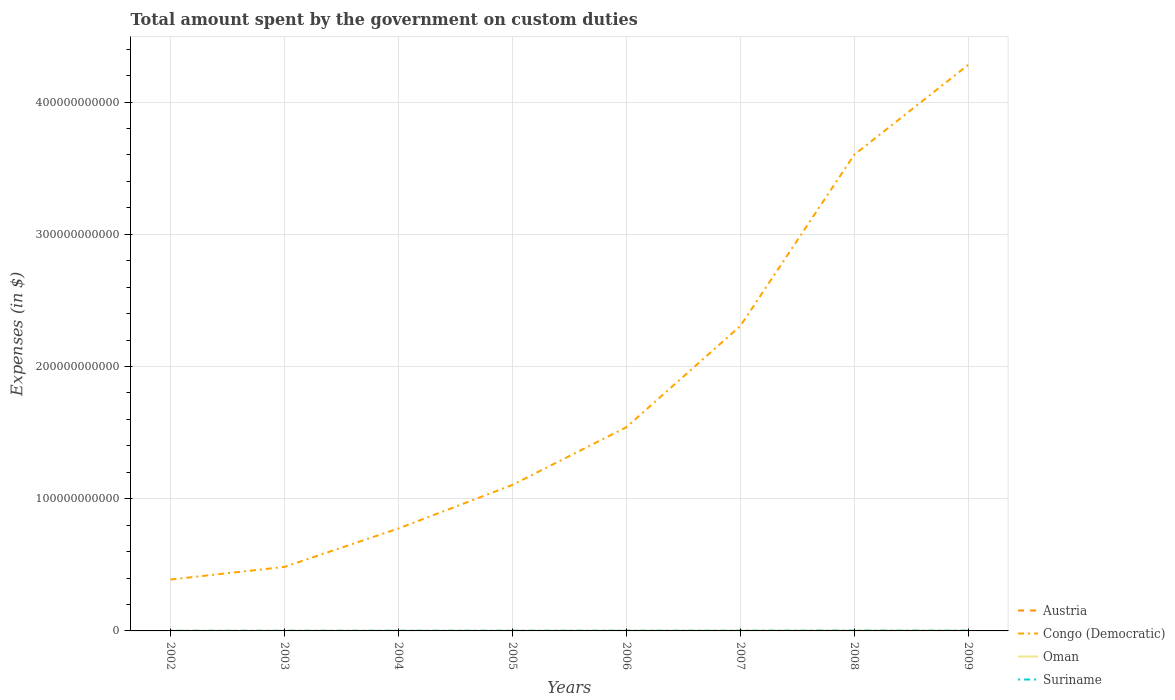How many different coloured lines are there?
Offer a terse response. 4. Does the line corresponding to Oman intersect with the line corresponding to Austria?
Keep it short and to the point. No. Is the number of lines equal to the number of legend labels?
Make the answer very short. No. Across all years, what is the maximum amount spent on custom duties by the government in Congo (Democratic)?
Provide a succinct answer. 3.89e+1. What is the total amount spent on custom duties by the government in Oman in the graph?
Offer a very short reply. -7.11e+07. What is the difference between the highest and the second highest amount spent on custom duties by the government in Austria?
Your response must be concise. 3.94e+06. What is the difference between the highest and the lowest amount spent on custom duties by the government in Congo (Democratic)?
Provide a succinct answer. 3. How many lines are there?
Your answer should be very brief. 4. How many years are there in the graph?
Provide a succinct answer. 8. What is the difference between two consecutive major ticks on the Y-axis?
Your answer should be compact. 1.00e+11. Are the values on the major ticks of Y-axis written in scientific E-notation?
Ensure brevity in your answer.  No. Does the graph contain any zero values?
Offer a terse response. Yes. Does the graph contain grids?
Your answer should be very brief. Yes. What is the title of the graph?
Provide a short and direct response. Total amount spent by the government on custom duties. What is the label or title of the X-axis?
Keep it short and to the point. Years. What is the label or title of the Y-axis?
Your response must be concise. Expenses (in $). What is the Expenses (in $) in Austria in 2002?
Make the answer very short. 0. What is the Expenses (in $) of Congo (Democratic) in 2002?
Offer a very short reply. 3.89e+1. What is the Expenses (in $) of Oman in 2002?
Provide a succinct answer. 6.02e+07. What is the Expenses (in $) of Suriname in 2002?
Your response must be concise. 1.07e+08. What is the Expenses (in $) of Austria in 2003?
Offer a very short reply. 0. What is the Expenses (in $) of Congo (Democratic) in 2003?
Provide a succinct answer. 4.84e+1. What is the Expenses (in $) of Oman in 2003?
Your answer should be very brief. 6.50e+07. What is the Expenses (in $) in Suriname in 2003?
Ensure brevity in your answer.  1.19e+08. What is the Expenses (in $) of Austria in 2004?
Your answer should be compact. 3.94e+06. What is the Expenses (in $) of Congo (Democratic) in 2004?
Your answer should be compact. 7.75e+1. What is the Expenses (in $) in Oman in 2004?
Give a very brief answer. 7.10e+07. What is the Expenses (in $) of Suriname in 2004?
Offer a terse response. 1.46e+08. What is the Expenses (in $) in Austria in 2005?
Offer a terse response. 1.43e+06. What is the Expenses (in $) of Congo (Democratic) in 2005?
Give a very brief answer. 1.10e+11. What is the Expenses (in $) in Oman in 2005?
Your response must be concise. 8.85e+07. What is the Expenses (in $) of Suriname in 2005?
Keep it short and to the point. 1.71e+08. What is the Expenses (in $) of Austria in 2006?
Your answer should be compact. 7.00e+04. What is the Expenses (in $) of Congo (Democratic) in 2006?
Your answer should be compact. 1.54e+11. What is the Expenses (in $) in Oman in 2006?
Keep it short and to the point. 1.15e+08. What is the Expenses (in $) of Suriname in 2006?
Ensure brevity in your answer.  1.60e+08. What is the Expenses (in $) in Austria in 2007?
Provide a succinct answer. 0. What is the Expenses (in $) of Congo (Democratic) in 2007?
Offer a very short reply. 2.31e+11. What is the Expenses (in $) in Oman in 2007?
Offer a very short reply. 1.60e+08. What is the Expenses (in $) in Suriname in 2007?
Provide a short and direct response. 1.85e+08. What is the Expenses (in $) of Austria in 2008?
Your answer should be compact. 0. What is the Expenses (in $) of Congo (Democratic) in 2008?
Ensure brevity in your answer.  3.60e+11. What is the Expenses (in $) in Oman in 2008?
Provide a succinct answer. 2.27e+08. What is the Expenses (in $) in Suriname in 2008?
Your answer should be compact. 2.22e+08. What is the Expenses (in $) of Congo (Democratic) in 2009?
Make the answer very short. 4.28e+11. What is the Expenses (in $) of Oman in 2009?
Keep it short and to the point. 1.58e+08. What is the Expenses (in $) of Suriname in 2009?
Make the answer very short. 2.12e+08. Across all years, what is the maximum Expenses (in $) of Austria?
Offer a very short reply. 3.94e+06. Across all years, what is the maximum Expenses (in $) in Congo (Democratic)?
Your answer should be compact. 4.28e+11. Across all years, what is the maximum Expenses (in $) in Oman?
Make the answer very short. 2.27e+08. Across all years, what is the maximum Expenses (in $) of Suriname?
Provide a short and direct response. 2.22e+08. Across all years, what is the minimum Expenses (in $) in Congo (Democratic)?
Provide a short and direct response. 3.89e+1. Across all years, what is the minimum Expenses (in $) in Oman?
Offer a terse response. 6.02e+07. Across all years, what is the minimum Expenses (in $) of Suriname?
Provide a succinct answer. 1.07e+08. What is the total Expenses (in $) in Austria in the graph?
Make the answer very short. 5.51e+06. What is the total Expenses (in $) of Congo (Democratic) in the graph?
Ensure brevity in your answer.  1.45e+12. What is the total Expenses (in $) in Oman in the graph?
Your response must be concise. 9.44e+08. What is the total Expenses (in $) of Suriname in the graph?
Keep it short and to the point. 1.32e+09. What is the difference between the Expenses (in $) of Congo (Democratic) in 2002 and that in 2003?
Keep it short and to the point. -9.55e+09. What is the difference between the Expenses (in $) in Oman in 2002 and that in 2003?
Provide a succinct answer. -4.80e+06. What is the difference between the Expenses (in $) in Suriname in 2002 and that in 2003?
Give a very brief answer. -1.16e+07. What is the difference between the Expenses (in $) of Congo (Democratic) in 2002 and that in 2004?
Make the answer very short. -3.86e+1. What is the difference between the Expenses (in $) of Oman in 2002 and that in 2004?
Offer a very short reply. -1.08e+07. What is the difference between the Expenses (in $) in Suriname in 2002 and that in 2004?
Provide a succinct answer. -3.92e+07. What is the difference between the Expenses (in $) in Congo (Democratic) in 2002 and that in 2005?
Offer a very short reply. -7.15e+1. What is the difference between the Expenses (in $) in Oman in 2002 and that in 2005?
Your response must be concise. -2.83e+07. What is the difference between the Expenses (in $) in Suriname in 2002 and that in 2005?
Your answer should be very brief. -6.34e+07. What is the difference between the Expenses (in $) of Congo (Democratic) in 2002 and that in 2006?
Your answer should be compact. -1.15e+11. What is the difference between the Expenses (in $) of Oman in 2002 and that in 2006?
Offer a terse response. -5.44e+07. What is the difference between the Expenses (in $) of Suriname in 2002 and that in 2006?
Your answer should be very brief. -5.29e+07. What is the difference between the Expenses (in $) in Congo (Democratic) in 2002 and that in 2007?
Your response must be concise. -1.92e+11. What is the difference between the Expenses (in $) of Oman in 2002 and that in 2007?
Offer a very short reply. -9.94e+07. What is the difference between the Expenses (in $) of Suriname in 2002 and that in 2007?
Your response must be concise. -7.76e+07. What is the difference between the Expenses (in $) of Congo (Democratic) in 2002 and that in 2008?
Your answer should be compact. -3.21e+11. What is the difference between the Expenses (in $) of Oman in 2002 and that in 2008?
Ensure brevity in your answer.  -1.66e+08. What is the difference between the Expenses (in $) in Suriname in 2002 and that in 2008?
Give a very brief answer. -1.15e+08. What is the difference between the Expenses (in $) in Congo (Democratic) in 2002 and that in 2009?
Keep it short and to the point. -3.89e+11. What is the difference between the Expenses (in $) in Oman in 2002 and that in 2009?
Offer a terse response. -9.79e+07. What is the difference between the Expenses (in $) in Suriname in 2002 and that in 2009?
Your answer should be very brief. -1.05e+08. What is the difference between the Expenses (in $) of Congo (Democratic) in 2003 and that in 2004?
Offer a very short reply. -2.91e+1. What is the difference between the Expenses (in $) of Oman in 2003 and that in 2004?
Offer a very short reply. -6.00e+06. What is the difference between the Expenses (in $) of Suriname in 2003 and that in 2004?
Ensure brevity in your answer.  -2.77e+07. What is the difference between the Expenses (in $) in Congo (Democratic) in 2003 and that in 2005?
Offer a very short reply. -6.20e+1. What is the difference between the Expenses (in $) of Oman in 2003 and that in 2005?
Ensure brevity in your answer.  -2.35e+07. What is the difference between the Expenses (in $) in Suriname in 2003 and that in 2005?
Your response must be concise. -5.18e+07. What is the difference between the Expenses (in $) of Congo (Democratic) in 2003 and that in 2006?
Offer a very short reply. -1.06e+11. What is the difference between the Expenses (in $) of Oman in 2003 and that in 2006?
Your answer should be compact. -4.96e+07. What is the difference between the Expenses (in $) in Suriname in 2003 and that in 2006?
Your response must be concise. -4.13e+07. What is the difference between the Expenses (in $) in Congo (Democratic) in 2003 and that in 2007?
Provide a succinct answer. -1.82e+11. What is the difference between the Expenses (in $) in Oman in 2003 and that in 2007?
Provide a succinct answer. -9.46e+07. What is the difference between the Expenses (in $) in Suriname in 2003 and that in 2007?
Your answer should be very brief. -6.61e+07. What is the difference between the Expenses (in $) of Congo (Democratic) in 2003 and that in 2008?
Ensure brevity in your answer.  -3.12e+11. What is the difference between the Expenses (in $) in Oman in 2003 and that in 2008?
Your answer should be compact. -1.62e+08. What is the difference between the Expenses (in $) in Suriname in 2003 and that in 2008?
Provide a succinct answer. -1.03e+08. What is the difference between the Expenses (in $) of Congo (Democratic) in 2003 and that in 2009?
Your response must be concise. -3.80e+11. What is the difference between the Expenses (in $) in Oman in 2003 and that in 2009?
Your response must be concise. -9.31e+07. What is the difference between the Expenses (in $) in Suriname in 2003 and that in 2009?
Provide a short and direct response. -9.31e+07. What is the difference between the Expenses (in $) in Austria in 2004 and that in 2005?
Offer a terse response. 2.51e+06. What is the difference between the Expenses (in $) in Congo (Democratic) in 2004 and that in 2005?
Your answer should be compact. -3.29e+1. What is the difference between the Expenses (in $) of Oman in 2004 and that in 2005?
Give a very brief answer. -1.75e+07. What is the difference between the Expenses (in $) of Suriname in 2004 and that in 2005?
Give a very brief answer. -2.42e+07. What is the difference between the Expenses (in $) in Austria in 2004 and that in 2006?
Offer a terse response. 3.87e+06. What is the difference between the Expenses (in $) of Congo (Democratic) in 2004 and that in 2006?
Your answer should be compact. -7.66e+1. What is the difference between the Expenses (in $) of Oman in 2004 and that in 2006?
Give a very brief answer. -4.36e+07. What is the difference between the Expenses (in $) of Suriname in 2004 and that in 2006?
Offer a very short reply. -1.37e+07. What is the difference between the Expenses (in $) in Congo (Democratic) in 2004 and that in 2007?
Your answer should be very brief. -1.53e+11. What is the difference between the Expenses (in $) in Oman in 2004 and that in 2007?
Your answer should be very brief. -8.86e+07. What is the difference between the Expenses (in $) in Suriname in 2004 and that in 2007?
Your answer should be very brief. -3.84e+07. What is the difference between the Expenses (in $) in Congo (Democratic) in 2004 and that in 2008?
Keep it short and to the point. -2.83e+11. What is the difference between the Expenses (in $) in Oman in 2004 and that in 2008?
Your answer should be compact. -1.56e+08. What is the difference between the Expenses (in $) of Suriname in 2004 and that in 2008?
Provide a short and direct response. -7.55e+07. What is the difference between the Expenses (in $) in Austria in 2004 and that in 2009?
Make the answer very short. 3.87e+06. What is the difference between the Expenses (in $) in Congo (Democratic) in 2004 and that in 2009?
Provide a short and direct response. -3.51e+11. What is the difference between the Expenses (in $) in Oman in 2004 and that in 2009?
Offer a very short reply. -8.71e+07. What is the difference between the Expenses (in $) in Suriname in 2004 and that in 2009?
Give a very brief answer. -6.54e+07. What is the difference between the Expenses (in $) in Austria in 2005 and that in 2006?
Offer a terse response. 1.36e+06. What is the difference between the Expenses (in $) in Congo (Democratic) in 2005 and that in 2006?
Keep it short and to the point. -4.36e+1. What is the difference between the Expenses (in $) of Oman in 2005 and that in 2006?
Your response must be concise. -2.61e+07. What is the difference between the Expenses (in $) of Suriname in 2005 and that in 2006?
Make the answer very short. 1.05e+07. What is the difference between the Expenses (in $) of Congo (Democratic) in 2005 and that in 2007?
Keep it short and to the point. -1.20e+11. What is the difference between the Expenses (in $) of Oman in 2005 and that in 2007?
Ensure brevity in your answer.  -7.11e+07. What is the difference between the Expenses (in $) in Suriname in 2005 and that in 2007?
Your answer should be very brief. -1.43e+07. What is the difference between the Expenses (in $) in Congo (Democratic) in 2005 and that in 2008?
Make the answer very short. -2.50e+11. What is the difference between the Expenses (in $) in Oman in 2005 and that in 2008?
Keep it short and to the point. -1.38e+08. What is the difference between the Expenses (in $) in Suriname in 2005 and that in 2008?
Your answer should be very brief. -5.14e+07. What is the difference between the Expenses (in $) in Austria in 2005 and that in 2009?
Give a very brief answer. 1.36e+06. What is the difference between the Expenses (in $) of Congo (Democratic) in 2005 and that in 2009?
Provide a succinct answer. -3.18e+11. What is the difference between the Expenses (in $) of Oman in 2005 and that in 2009?
Provide a succinct answer. -6.96e+07. What is the difference between the Expenses (in $) in Suriname in 2005 and that in 2009?
Offer a terse response. -4.13e+07. What is the difference between the Expenses (in $) in Congo (Democratic) in 2006 and that in 2007?
Make the answer very short. -7.66e+1. What is the difference between the Expenses (in $) of Oman in 2006 and that in 2007?
Ensure brevity in your answer.  -4.50e+07. What is the difference between the Expenses (in $) of Suriname in 2006 and that in 2007?
Provide a short and direct response. -2.47e+07. What is the difference between the Expenses (in $) in Congo (Democratic) in 2006 and that in 2008?
Provide a short and direct response. -2.06e+11. What is the difference between the Expenses (in $) of Oman in 2006 and that in 2008?
Offer a very short reply. -1.12e+08. What is the difference between the Expenses (in $) in Suriname in 2006 and that in 2008?
Give a very brief answer. -6.18e+07. What is the difference between the Expenses (in $) in Austria in 2006 and that in 2009?
Provide a succinct answer. 0. What is the difference between the Expenses (in $) in Congo (Democratic) in 2006 and that in 2009?
Your answer should be very brief. -2.74e+11. What is the difference between the Expenses (in $) of Oman in 2006 and that in 2009?
Your response must be concise. -4.35e+07. What is the difference between the Expenses (in $) of Suriname in 2006 and that in 2009?
Offer a very short reply. -5.17e+07. What is the difference between the Expenses (in $) in Congo (Democratic) in 2007 and that in 2008?
Keep it short and to the point. -1.30e+11. What is the difference between the Expenses (in $) of Oman in 2007 and that in 2008?
Your answer should be compact. -6.70e+07. What is the difference between the Expenses (in $) in Suriname in 2007 and that in 2008?
Your response must be concise. -3.71e+07. What is the difference between the Expenses (in $) in Congo (Democratic) in 2007 and that in 2009?
Give a very brief answer. -1.98e+11. What is the difference between the Expenses (in $) of Oman in 2007 and that in 2009?
Offer a very short reply. 1.50e+06. What is the difference between the Expenses (in $) of Suriname in 2007 and that in 2009?
Your response must be concise. -2.70e+07. What is the difference between the Expenses (in $) of Congo (Democratic) in 2008 and that in 2009?
Provide a succinct answer. -6.80e+1. What is the difference between the Expenses (in $) of Oman in 2008 and that in 2009?
Keep it short and to the point. 6.85e+07. What is the difference between the Expenses (in $) in Suriname in 2008 and that in 2009?
Provide a succinct answer. 1.01e+07. What is the difference between the Expenses (in $) of Congo (Democratic) in 2002 and the Expenses (in $) of Oman in 2003?
Provide a short and direct response. 3.88e+1. What is the difference between the Expenses (in $) in Congo (Democratic) in 2002 and the Expenses (in $) in Suriname in 2003?
Your answer should be compact. 3.87e+1. What is the difference between the Expenses (in $) in Oman in 2002 and the Expenses (in $) in Suriname in 2003?
Your answer should be very brief. -5.85e+07. What is the difference between the Expenses (in $) in Congo (Democratic) in 2002 and the Expenses (in $) in Oman in 2004?
Your response must be concise. 3.88e+1. What is the difference between the Expenses (in $) of Congo (Democratic) in 2002 and the Expenses (in $) of Suriname in 2004?
Your response must be concise. 3.87e+1. What is the difference between the Expenses (in $) of Oman in 2002 and the Expenses (in $) of Suriname in 2004?
Offer a terse response. -8.62e+07. What is the difference between the Expenses (in $) in Congo (Democratic) in 2002 and the Expenses (in $) in Oman in 2005?
Provide a succinct answer. 3.88e+1. What is the difference between the Expenses (in $) in Congo (Democratic) in 2002 and the Expenses (in $) in Suriname in 2005?
Your answer should be compact. 3.87e+1. What is the difference between the Expenses (in $) in Oman in 2002 and the Expenses (in $) in Suriname in 2005?
Ensure brevity in your answer.  -1.10e+08. What is the difference between the Expenses (in $) in Congo (Democratic) in 2002 and the Expenses (in $) in Oman in 2006?
Keep it short and to the point. 3.87e+1. What is the difference between the Expenses (in $) in Congo (Democratic) in 2002 and the Expenses (in $) in Suriname in 2006?
Your answer should be very brief. 3.87e+1. What is the difference between the Expenses (in $) of Oman in 2002 and the Expenses (in $) of Suriname in 2006?
Offer a terse response. -9.99e+07. What is the difference between the Expenses (in $) of Congo (Democratic) in 2002 and the Expenses (in $) of Oman in 2007?
Keep it short and to the point. 3.87e+1. What is the difference between the Expenses (in $) in Congo (Democratic) in 2002 and the Expenses (in $) in Suriname in 2007?
Ensure brevity in your answer.  3.87e+1. What is the difference between the Expenses (in $) of Oman in 2002 and the Expenses (in $) of Suriname in 2007?
Provide a succinct answer. -1.25e+08. What is the difference between the Expenses (in $) in Congo (Democratic) in 2002 and the Expenses (in $) in Oman in 2008?
Your response must be concise. 3.86e+1. What is the difference between the Expenses (in $) of Congo (Democratic) in 2002 and the Expenses (in $) of Suriname in 2008?
Provide a succinct answer. 3.86e+1. What is the difference between the Expenses (in $) in Oman in 2002 and the Expenses (in $) in Suriname in 2008?
Make the answer very short. -1.62e+08. What is the difference between the Expenses (in $) in Congo (Democratic) in 2002 and the Expenses (in $) in Oman in 2009?
Your answer should be compact. 3.87e+1. What is the difference between the Expenses (in $) in Congo (Democratic) in 2002 and the Expenses (in $) in Suriname in 2009?
Provide a succinct answer. 3.86e+1. What is the difference between the Expenses (in $) of Oman in 2002 and the Expenses (in $) of Suriname in 2009?
Provide a short and direct response. -1.52e+08. What is the difference between the Expenses (in $) in Congo (Democratic) in 2003 and the Expenses (in $) in Oman in 2004?
Your response must be concise. 4.83e+1. What is the difference between the Expenses (in $) of Congo (Democratic) in 2003 and the Expenses (in $) of Suriname in 2004?
Provide a short and direct response. 4.83e+1. What is the difference between the Expenses (in $) of Oman in 2003 and the Expenses (in $) of Suriname in 2004?
Give a very brief answer. -8.14e+07. What is the difference between the Expenses (in $) in Congo (Democratic) in 2003 and the Expenses (in $) in Oman in 2005?
Keep it short and to the point. 4.83e+1. What is the difference between the Expenses (in $) of Congo (Democratic) in 2003 and the Expenses (in $) of Suriname in 2005?
Provide a succinct answer. 4.82e+1. What is the difference between the Expenses (in $) in Oman in 2003 and the Expenses (in $) in Suriname in 2005?
Offer a terse response. -1.06e+08. What is the difference between the Expenses (in $) of Congo (Democratic) in 2003 and the Expenses (in $) of Oman in 2006?
Ensure brevity in your answer.  4.83e+1. What is the difference between the Expenses (in $) of Congo (Democratic) in 2003 and the Expenses (in $) of Suriname in 2006?
Provide a short and direct response. 4.83e+1. What is the difference between the Expenses (in $) of Oman in 2003 and the Expenses (in $) of Suriname in 2006?
Offer a very short reply. -9.51e+07. What is the difference between the Expenses (in $) in Congo (Democratic) in 2003 and the Expenses (in $) in Oman in 2007?
Give a very brief answer. 4.83e+1. What is the difference between the Expenses (in $) in Congo (Democratic) in 2003 and the Expenses (in $) in Suriname in 2007?
Offer a terse response. 4.82e+1. What is the difference between the Expenses (in $) of Oman in 2003 and the Expenses (in $) of Suriname in 2007?
Offer a terse response. -1.20e+08. What is the difference between the Expenses (in $) of Congo (Democratic) in 2003 and the Expenses (in $) of Oman in 2008?
Keep it short and to the point. 4.82e+1. What is the difference between the Expenses (in $) of Congo (Democratic) in 2003 and the Expenses (in $) of Suriname in 2008?
Your answer should be compact. 4.82e+1. What is the difference between the Expenses (in $) in Oman in 2003 and the Expenses (in $) in Suriname in 2008?
Keep it short and to the point. -1.57e+08. What is the difference between the Expenses (in $) of Congo (Democratic) in 2003 and the Expenses (in $) of Oman in 2009?
Provide a succinct answer. 4.83e+1. What is the difference between the Expenses (in $) of Congo (Democratic) in 2003 and the Expenses (in $) of Suriname in 2009?
Offer a terse response. 4.82e+1. What is the difference between the Expenses (in $) in Oman in 2003 and the Expenses (in $) in Suriname in 2009?
Make the answer very short. -1.47e+08. What is the difference between the Expenses (in $) of Austria in 2004 and the Expenses (in $) of Congo (Democratic) in 2005?
Ensure brevity in your answer.  -1.10e+11. What is the difference between the Expenses (in $) in Austria in 2004 and the Expenses (in $) in Oman in 2005?
Keep it short and to the point. -8.46e+07. What is the difference between the Expenses (in $) of Austria in 2004 and the Expenses (in $) of Suriname in 2005?
Your answer should be compact. -1.67e+08. What is the difference between the Expenses (in $) in Congo (Democratic) in 2004 and the Expenses (in $) in Oman in 2005?
Your response must be concise. 7.74e+1. What is the difference between the Expenses (in $) in Congo (Democratic) in 2004 and the Expenses (in $) in Suriname in 2005?
Keep it short and to the point. 7.73e+1. What is the difference between the Expenses (in $) in Oman in 2004 and the Expenses (in $) in Suriname in 2005?
Keep it short and to the point. -9.95e+07. What is the difference between the Expenses (in $) in Austria in 2004 and the Expenses (in $) in Congo (Democratic) in 2006?
Provide a short and direct response. -1.54e+11. What is the difference between the Expenses (in $) of Austria in 2004 and the Expenses (in $) of Oman in 2006?
Give a very brief answer. -1.11e+08. What is the difference between the Expenses (in $) of Austria in 2004 and the Expenses (in $) of Suriname in 2006?
Your response must be concise. -1.56e+08. What is the difference between the Expenses (in $) in Congo (Democratic) in 2004 and the Expenses (in $) in Oman in 2006?
Make the answer very short. 7.73e+1. What is the difference between the Expenses (in $) of Congo (Democratic) in 2004 and the Expenses (in $) of Suriname in 2006?
Provide a succinct answer. 7.73e+1. What is the difference between the Expenses (in $) of Oman in 2004 and the Expenses (in $) of Suriname in 2006?
Ensure brevity in your answer.  -8.91e+07. What is the difference between the Expenses (in $) of Austria in 2004 and the Expenses (in $) of Congo (Democratic) in 2007?
Your answer should be compact. -2.31e+11. What is the difference between the Expenses (in $) of Austria in 2004 and the Expenses (in $) of Oman in 2007?
Offer a terse response. -1.56e+08. What is the difference between the Expenses (in $) of Austria in 2004 and the Expenses (in $) of Suriname in 2007?
Your answer should be compact. -1.81e+08. What is the difference between the Expenses (in $) in Congo (Democratic) in 2004 and the Expenses (in $) in Oman in 2007?
Keep it short and to the point. 7.73e+1. What is the difference between the Expenses (in $) of Congo (Democratic) in 2004 and the Expenses (in $) of Suriname in 2007?
Your answer should be very brief. 7.73e+1. What is the difference between the Expenses (in $) of Oman in 2004 and the Expenses (in $) of Suriname in 2007?
Provide a succinct answer. -1.14e+08. What is the difference between the Expenses (in $) of Austria in 2004 and the Expenses (in $) of Congo (Democratic) in 2008?
Make the answer very short. -3.60e+11. What is the difference between the Expenses (in $) in Austria in 2004 and the Expenses (in $) in Oman in 2008?
Ensure brevity in your answer.  -2.23e+08. What is the difference between the Expenses (in $) in Austria in 2004 and the Expenses (in $) in Suriname in 2008?
Your answer should be compact. -2.18e+08. What is the difference between the Expenses (in $) of Congo (Democratic) in 2004 and the Expenses (in $) of Oman in 2008?
Provide a succinct answer. 7.72e+1. What is the difference between the Expenses (in $) of Congo (Democratic) in 2004 and the Expenses (in $) of Suriname in 2008?
Provide a succinct answer. 7.72e+1. What is the difference between the Expenses (in $) in Oman in 2004 and the Expenses (in $) in Suriname in 2008?
Keep it short and to the point. -1.51e+08. What is the difference between the Expenses (in $) of Austria in 2004 and the Expenses (in $) of Congo (Democratic) in 2009?
Your response must be concise. -4.28e+11. What is the difference between the Expenses (in $) of Austria in 2004 and the Expenses (in $) of Oman in 2009?
Your response must be concise. -1.54e+08. What is the difference between the Expenses (in $) of Austria in 2004 and the Expenses (in $) of Suriname in 2009?
Provide a succinct answer. -2.08e+08. What is the difference between the Expenses (in $) in Congo (Democratic) in 2004 and the Expenses (in $) in Oman in 2009?
Make the answer very short. 7.73e+1. What is the difference between the Expenses (in $) of Congo (Democratic) in 2004 and the Expenses (in $) of Suriname in 2009?
Make the answer very short. 7.73e+1. What is the difference between the Expenses (in $) of Oman in 2004 and the Expenses (in $) of Suriname in 2009?
Offer a terse response. -1.41e+08. What is the difference between the Expenses (in $) in Austria in 2005 and the Expenses (in $) in Congo (Democratic) in 2006?
Ensure brevity in your answer.  -1.54e+11. What is the difference between the Expenses (in $) of Austria in 2005 and the Expenses (in $) of Oman in 2006?
Your answer should be very brief. -1.13e+08. What is the difference between the Expenses (in $) of Austria in 2005 and the Expenses (in $) of Suriname in 2006?
Keep it short and to the point. -1.59e+08. What is the difference between the Expenses (in $) in Congo (Democratic) in 2005 and the Expenses (in $) in Oman in 2006?
Offer a terse response. 1.10e+11. What is the difference between the Expenses (in $) of Congo (Democratic) in 2005 and the Expenses (in $) of Suriname in 2006?
Keep it short and to the point. 1.10e+11. What is the difference between the Expenses (in $) of Oman in 2005 and the Expenses (in $) of Suriname in 2006?
Make the answer very short. -7.16e+07. What is the difference between the Expenses (in $) in Austria in 2005 and the Expenses (in $) in Congo (Democratic) in 2007?
Your answer should be compact. -2.31e+11. What is the difference between the Expenses (in $) of Austria in 2005 and the Expenses (in $) of Oman in 2007?
Ensure brevity in your answer.  -1.58e+08. What is the difference between the Expenses (in $) of Austria in 2005 and the Expenses (in $) of Suriname in 2007?
Your answer should be very brief. -1.83e+08. What is the difference between the Expenses (in $) of Congo (Democratic) in 2005 and the Expenses (in $) of Oman in 2007?
Your response must be concise. 1.10e+11. What is the difference between the Expenses (in $) in Congo (Democratic) in 2005 and the Expenses (in $) in Suriname in 2007?
Offer a very short reply. 1.10e+11. What is the difference between the Expenses (in $) in Oman in 2005 and the Expenses (in $) in Suriname in 2007?
Keep it short and to the point. -9.63e+07. What is the difference between the Expenses (in $) in Austria in 2005 and the Expenses (in $) in Congo (Democratic) in 2008?
Offer a very short reply. -3.60e+11. What is the difference between the Expenses (in $) in Austria in 2005 and the Expenses (in $) in Oman in 2008?
Give a very brief answer. -2.25e+08. What is the difference between the Expenses (in $) in Austria in 2005 and the Expenses (in $) in Suriname in 2008?
Make the answer very short. -2.20e+08. What is the difference between the Expenses (in $) of Congo (Democratic) in 2005 and the Expenses (in $) of Oman in 2008?
Offer a very short reply. 1.10e+11. What is the difference between the Expenses (in $) in Congo (Democratic) in 2005 and the Expenses (in $) in Suriname in 2008?
Your response must be concise. 1.10e+11. What is the difference between the Expenses (in $) of Oman in 2005 and the Expenses (in $) of Suriname in 2008?
Ensure brevity in your answer.  -1.33e+08. What is the difference between the Expenses (in $) in Austria in 2005 and the Expenses (in $) in Congo (Democratic) in 2009?
Make the answer very short. -4.28e+11. What is the difference between the Expenses (in $) in Austria in 2005 and the Expenses (in $) in Oman in 2009?
Your answer should be compact. -1.57e+08. What is the difference between the Expenses (in $) in Austria in 2005 and the Expenses (in $) in Suriname in 2009?
Offer a terse response. -2.10e+08. What is the difference between the Expenses (in $) in Congo (Democratic) in 2005 and the Expenses (in $) in Oman in 2009?
Provide a succinct answer. 1.10e+11. What is the difference between the Expenses (in $) in Congo (Democratic) in 2005 and the Expenses (in $) in Suriname in 2009?
Ensure brevity in your answer.  1.10e+11. What is the difference between the Expenses (in $) of Oman in 2005 and the Expenses (in $) of Suriname in 2009?
Offer a very short reply. -1.23e+08. What is the difference between the Expenses (in $) of Austria in 2006 and the Expenses (in $) of Congo (Democratic) in 2007?
Your response must be concise. -2.31e+11. What is the difference between the Expenses (in $) in Austria in 2006 and the Expenses (in $) in Oman in 2007?
Make the answer very short. -1.60e+08. What is the difference between the Expenses (in $) in Austria in 2006 and the Expenses (in $) in Suriname in 2007?
Your answer should be compact. -1.85e+08. What is the difference between the Expenses (in $) in Congo (Democratic) in 2006 and the Expenses (in $) in Oman in 2007?
Ensure brevity in your answer.  1.54e+11. What is the difference between the Expenses (in $) of Congo (Democratic) in 2006 and the Expenses (in $) of Suriname in 2007?
Provide a short and direct response. 1.54e+11. What is the difference between the Expenses (in $) of Oman in 2006 and the Expenses (in $) of Suriname in 2007?
Make the answer very short. -7.02e+07. What is the difference between the Expenses (in $) of Austria in 2006 and the Expenses (in $) of Congo (Democratic) in 2008?
Offer a very short reply. -3.60e+11. What is the difference between the Expenses (in $) of Austria in 2006 and the Expenses (in $) of Oman in 2008?
Offer a very short reply. -2.27e+08. What is the difference between the Expenses (in $) of Austria in 2006 and the Expenses (in $) of Suriname in 2008?
Make the answer very short. -2.22e+08. What is the difference between the Expenses (in $) of Congo (Democratic) in 2006 and the Expenses (in $) of Oman in 2008?
Ensure brevity in your answer.  1.54e+11. What is the difference between the Expenses (in $) of Congo (Democratic) in 2006 and the Expenses (in $) of Suriname in 2008?
Offer a terse response. 1.54e+11. What is the difference between the Expenses (in $) of Oman in 2006 and the Expenses (in $) of Suriname in 2008?
Give a very brief answer. -1.07e+08. What is the difference between the Expenses (in $) in Austria in 2006 and the Expenses (in $) in Congo (Democratic) in 2009?
Offer a very short reply. -4.28e+11. What is the difference between the Expenses (in $) of Austria in 2006 and the Expenses (in $) of Oman in 2009?
Keep it short and to the point. -1.58e+08. What is the difference between the Expenses (in $) of Austria in 2006 and the Expenses (in $) of Suriname in 2009?
Make the answer very short. -2.12e+08. What is the difference between the Expenses (in $) of Congo (Democratic) in 2006 and the Expenses (in $) of Oman in 2009?
Provide a succinct answer. 1.54e+11. What is the difference between the Expenses (in $) of Congo (Democratic) in 2006 and the Expenses (in $) of Suriname in 2009?
Keep it short and to the point. 1.54e+11. What is the difference between the Expenses (in $) of Oman in 2006 and the Expenses (in $) of Suriname in 2009?
Offer a very short reply. -9.72e+07. What is the difference between the Expenses (in $) in Congo (Democratic) in 2007 and the Expenses (in $) in Oman in 2008?
Keep it short and to the point. 2.30e+11. What is the difference between the Expenses (in $) in Congo (Democratic) in 2007 and the Expenses (in $) in Suriname in 2008?
Offer a terse response. 2.30e+11. What is the difference between the Expenses (in $) of Oman in 2007 and the Expenses (in $) of Suriname in 2008?
Provide a short and direct response. -6.23e+07. What is the difference between the Expenses (in $) in Congo (Democratic) in 2007 and the Expenses (in $) in Oman in 2009?
Offer a terse response. 2.30e+11. What is the difference between the Expenses (in $) of Congo (Democratic) in 2007 and the Expenses (in $) of Suriname in 2009?
Your response must be concise. 2.30e+11. What is the difference between the Expenses (in $) of Oman in 2007 and the Expenses (in $) of Suriname in 2009?
Provide a succinct answer. -5.22e+07. What is the difference between the Expenses (in $) in Congo (Democratic) in 2008 and the Expenses (in $) in Oman in 2009?
Ensure brevity in your answer.  3.60e+11. What is the difference between the Expenses (in $) of Congo (Democratic) in 2008 and the Expenses (in $) of Suriname in 2009?
Provide a succinct answer. 3.60e+11. What is the difference between the Expenses (in $) of Oman in 2008 and the Expenses (in $) of Suriname in 2009?
Your answer should be very brief. 1.48e+07. What is the average Expenses (in $) of Austria per year?
Provide a succinct answer. 6.89e+05. What is the average Expenses (in $) of Congo (Democratic) per year?
Your answer should be very brief. 1.81e+11. What is the average Expenses (in $) in Oman per year?
Make the answer very short. 1.18e+08. What is the average Expenses (in $) in Suriname per year?
Ensure brevity in your answer.  1.65e+08. In the year 2002, what is the difference between the Expenses (in $) in Congo (Democratic) and Expenses (in $) in Oman?
Your response must be concise. 3.88e+1. In the year 2002, what is the difference between the Expenses (in $) of Congo (Democratic) and Expenses (in $) of Suriname?
Make the answer very short. 3.88e+1. In the year 2002, what is the difference between the Expenses (in $) in Oman and Expenses (in $) in Suriname?
Give a very brief answer. -4.70e+07. In the year 2003, what is the difference between the Expenses (in $) in Congo (Democratic) and Expenses (in $) in Oman?
Your response must be concise. 4.83e+1. In the year 2003, what is the difference between the Expenses (in $) of Congo (Democratic) and Expenses (in $) of Suriname?
Make the answer very short. 4.83e+1. In the year 2003, what is the difference between the Expenses (in $) of Oman and Expenses (in $) of Suriname?
Offer a terse response. -5.37e+07. In the year 2004, what is the difference between the Expenses (in $) of Austria and Expenses (in $) of Congo (Democratic)?
Offer a very short reply. -7.75e+1. In the year 2004, what is the difference between the Expenses (in $) in Austria and Expenses (in $) in Oman?
Your answer should be very brief. -6.71e+07. In the year 2004, what is the difference between the Expenses (in $) of Austria and Expenses (in $) of Suriname?
Provide a short and direct response. -1.42e+08. In the year 2004, what is the difference between the Expenses (in $) in Congo (Democratic) and Expenses (in $) in Oman?
Your answer should be very brief. 7.74e+1. In the year 2004, what is the difference between the Expenses (in $) in Congo (Democratic) and Expenses (in $) in Suriname?
Give a very brief answer. 7.73e+1. In the year 2004, what is the difference between the Expenses (in $) in Oman and Expenses (in $) in Suriname?
Your answer should be very brief. -7.54e+07. In the year 2005, what is the difference between the Expenses (in $) in Austria and Expenses (in $) in Congo (Democratic)?
Your response must be concise. -1.10e+11. In the year 2005, what is the difference between the Expenses (in $) in Austria and Expenses (in $) in Oman?
Keep it short and to the point. -8.71e+07. In the year 2005, what is the difference between the Expenses (in $) in Austria and Expenses (in $) in Suriname?
Your answer should be compact. -1.69e+08. In the year 2005, what is the difference between the Expenses (in $) in Congo (Democratic) and Expenses (in $) in Oman?
Offer a very short reply. 1.10e+11. In the year 2005, what is the difference between the Expenses (in $) in Congo (Democratic) and Expenses (in $) in Suriname?
Offer a terse response. 1.10e+11. In the year 2005, what is the difference between the Expenses (in $) of Oman and Expenses (in $) of Suriname?
Make the answer very short. -8.20e+07. In the year 2006, what is the difference between the Expenses (in $) of Austria and Expenses (in $) of Congo (Democratic)?
Give a very brief answer. -1.54e+11. In the year 2006, what is the difference between the Expenses (in $) of Austria and Expenses (in $) of Oman?
Give a very brief answer. -1.15e+08. In the year 2006, what is the difference between the Expenses (in $) of Austria and Expenses (in $) of Suriname?
Offer a very short reply. -1.60e+08. In the year 2006, what is the difference between the Expenses (in $) in Congo (Democratic) and Expenses (in $) in Oman?
Offer a terse response. 1.54e+11. In the year 2006, what is the difference between the Expenses (in $) in Congo (Democratic) and Expenses (in $) in Suriname?
Make the answer very short. 1.54e+11. In the year 2006, what is the difference between the Expenses (in $) in Oman and Expenses (in $) in Suriname?
Provide a short and direct response. -4.55e+07. In the year 2007, what is the difference between the Expenses (in $) in Congo (Democratic) and Expenses (in $) in Oman?
Your answer should be compact. 2.30e+11. In the year 2007, what is the difference between the Expenses (in $) in Congo (Democratic) and Expenses (in $) in Suriname?
Make the answer very short. 2.30e+11. In the year 2007, what is the difference between the Expenses (in $) in Oman and Expenses (in $) in Suriname?
Keep it short and to the point. -2.52e+07. In the year 2008, what is the difference between the Expenses (in $) of Congo (Democratic) and Expenses (in $) of Oman?
Provide a succinct answer. 3.60e+11. In the year 2008, what is the difference between the Expenses (in $) of Congo (Democratic) and Expenses (in $) of Suriname?
Your response must be concise. 3.60e+11. In the year 2008, what is the difference between the Expenses (in $) of Oman and Expenses (in $) of Suriname?
Provide a short and direct response. 4.69e+06. In the year 2009, what is the difference between the Expenses (in $) of Austria and Expenses (in $) of Congo (Democratic)?
Your answer should be compact. -4.28e+11. In the year 2009, what is the difference between the Expenses (in $) in Austria and Expenses (in $) in Oman?
Keep it short and to the point. -1.58e+08. In the year 2009, what is the difference between the Expenses (in $) in Austria and Expenses (in $) in Suriname?
Keep it short and to the point. -2.12e+08. In the year 2009, what is the difference between the Expenses (in $) in Congo (Democratic) and Expenses (in $) in Oman?
Give a very brief answer. 4.28e+11. In the year 2009, what is the difference between the Expenses (in $) of Congo (Democratic) and Expenses (in $) of Suriname?
Provide a succinct answer. 4.28e+11. In the year 2009, what is the difference between the Expenses (in $) of Oman and Expenses (in $) of Suriname?
Give a very brief answer. -5.37e+07. What is the ratio of the Expenses (in $) of Congo (Democratic) in 2002 to that in 2003?
Keep it short and to the point. 0.8. What is the ratio of the Expenses (in $) of Oman in 2002 to that in 2003?
Your answer should be very brief. 0.93. What is the ratio of the Expenses (in $) in Suriname in 2002 to that in 2003?
Keep it short and to the point. 0.9. What is the ratio of the Expenses (in $) of Congo (Democratic) in 2002 to that in 2004?
Give a very brief answer. 0.5. What is the ratio of the Expenses (in $) in Oman in 2002 to that in 2004?
Provide a short and direct response. 0.85. What is the ratio of the Expenses (in $) of Suriname in 2002 to that in 2004?
Provide a succinct answer. 0.73. What is the ratio of the Expenses (in $) in Congo (Democratic) in 2002 to that in 2005?
Your answer should be very brief. 0.35. What is the ratio of the Expenses (in $) of Oman in 2002 to that in 2005?
Your response must be concise. 0.68. What is the ratio of the Expenses (in $) of Suriname in 2002 to that in 2005?
Ensure brevity in your answer.  0.63. What is the ratio of the Expenses (in $) in Congo (Democratic) in 2002 to that in 2006?
Provide a short and direct response. 0.25. What is the ratio of the Expenses (in $) in Oman in 2002 to that in 2006?
Keep it short and to the point. 0.53. What is the ratio of the Expenses (in $) of Suriname in 2002 to that in 2006?
Your response must be concise. 0.67. What is the ratio of the Expenses (in $) of Congo (Democratic) in 2002 to that in 2007?
Offer a terse response. 0.17. What is the ratio of the Expenses (in $) of Oman in 2002 to that in 2007?
Your answer should be compact. 0.38. What is the ratio of the Expenses (in $) of Suriname in 2002 to that in 2007?
Your answer should be very brief. 0.58. What is the ratio of the Expenses (in $) of Congo (Democratic) in 2002 to that in 2008?
Keep it short and to the point. 0.11. What is the ratio of the Expenses (in $) in Oman in 2002 to that in 2008?
Provide a succinct answer. 0.27. What is the ratio of the Expenses (in $) of Suriname in 2002 to that in 2008?
Your answer should be very brief. 0.48. What is the ratio of the Expenses (in $) in Congo (Democratic) in 2002 to that in 2009?
Your answer should be compact. 0.09. What is the ratio of the Expenses (in $) of Oman in 2002 to that in 2009?
Offer a very short reply. 0.38. What is the ratio of the Expenses (in $) in Suriname in 2002 to that in 2009?
Ensure brevity in your answer.  0.51. What is the ratio of the Expenses (in $) of Oman in 2003 to that in 2004?
Offer a terse response. 0.92. What is the ratio of the Expenses (in $) in Suriname in 2003 to that in 2004?
Your response must be concise. 0.81. What is the ratio of the Expenses (in $) in Congo (Democratic) in 2003 to that in 2005?
Your answer should be compact. 0.44. What is the ratio of the Expenses (in $) in Oman in 2003 to that in 2005?
Offer a very short reply. 0.73. What is the ratio of the Expenses (in $) of Suriname in 2003 to that in 2005?
Give a very brief answer. 0.7. What is the ratio of the Expenses (in $) in Congo (Democratic) in 2003 to that in 2006?
Your response must be concise. 0.31. What is the ratio of the Expenses (in $) in Oman in 2003 to that in 2006?
Offer a terse response. 0.57. What is the ratio of the Expenses (in $) of Suriname in 2003 to that in 2006?
Your answer should be compact. 0.74. What is the ratio of the Expenses (in $) of Congo (Democratic) in 2003 to that in 2007?
Keep it short and to the point. 0.21. What is the ratio of the Expenses (in $) in Oman in 2003 to that in 2007?
Provide a succinct answer. 0.41. What is the ratio of the Expenses (in $) in Suriname in 2003 to that in 2007?
Offer a very short reply. 0.64. What is the ratio of the Expenses (in $) of Congo (Democratic) in 2003 to that in 2008?
Provide a short and direct response. 0.13. What is the ratio of the Expenses (in $) in Oman in 2003 to that in 2008?
Keep it short and to the point. 0.29. What is the ratio of the Expenses (in $) of Suriname in 2003 to that in 2008?
Give a very brief answer. 0.54. What is the ratio of the Expenses (in $) of Congo (Democratic) in 2003 to that in 2009?
Provide a short and direct response. 0.11. What is the ratio of the Expenses (in $) of Oman in 2003 to that in 2009?
Provide a short and direct response. 0.41. What is the ratio of the Expenses (in $) of Suriname in 2003 to that in 2009?
Make the answer very short. 0.56. What is the ratio of the Expenses (in $) of Austria in 2004 to that in 2005?
Your answer should be compact. 2.76. What is the ratio of the Expenses (in $) of Congo (Democratic) in 2004 to that in 2005?
Ensure brevity in your answer.  0.7. What is the ratio of the Expenses (in $) in Oman in 2004 to that in 2005?
Provide a succinct answer. 0.8. What is the ratio of the Expenses (in $) of Suriname in 2004 to that in 2005?
Give a very brief answer. 0.86. What is the ratio of the Expenses (in $) of Austria in 2004 to that in 2006?
Offer a terse response. 56.29. What is the ratio of the Expenses (in $) in Congo (Democratic) in 2004 to that in 2006?
Your answer should be very brief. 0.5. What is the ratio of the Expenses (in $) in Oman in 2004 to that in 2006?
Offer a very short reply. 0.62. What is the ratio of the Expenses (in $) of Suriname in 2004 to that in 2006?
Your answer should be very brief. 0.91. What is the ratio of the Expenses (in $) in Congo (Democratic) in 2004 to that in 2007?
Your response must be concise. 0.34. What is the ratio of the Expenses (in $) in Oman in 2004 to that in 2007?
Your response must be concise. 0.44. What is the ratio of the Expenses (in $) in Suriname in 2004 to that in 2007?
Keep it short and to the point. 0.79. What is the ratio of the Expenses (in $) in Congo (Democratic) in 2004 to that in 2008?
Ensure brevity in your answer.  0.22. What is the ratio of the Expenses (in $) in Oman in 2004 to that in 2008?
Provide a short and direct response. 0.31. What is the ratio of the Expenses (in $) of Suriname in 2004 to that in 2008?
Offer a terse response. 0.66. What is the ratio of the Expenses (in $) in Austria in 2004 to that in 2009?
Offer a terse response. 56.29. What is the ratio of the Expenses (in $) of Congo (Democratic) in 2004 to that in 2009?
Your answer should be very brief. 0.18. What is the ratio of the Expenses (in $) in Oman in 2004 to that in 2009?
Give a very brief answer. 0.45. What is the ratio of the Expenses (in $) of Suriname in 2004 to that in 2009?
Provide a short and direct response. 0.69. What is the ratio of the Expenses (in $) of Austria in 2005 to that in 2006?
Your answer should be very brief. 20.43. What is the ratio of the Expenses (in $) of Congo (Democratic) in 2005 to that in 2006?
Ensure brevity in your answer.  0.72. What is the ratio of the Expenses (in $) of Oman in 2005 to that in 2006?
Offer a terse response. 0.77. What is the ratio of the Expenses (in $) in Suriname in 2005 to that in 2006?
Provide a succinct answer. 1.07. What is the ratio of the Expenses (in $) of Congo (Democratic) in 2005 to that in 2007?
Your answer should be very brief. 0.48. What is the ratio of the Expenses (in $) of Oman in 2005 to that in 2007?
Offer a terse response. 0.55. What is the ratio of the Expenses (in $) in Suriname in 2005 to that in 2007?
Your answer should be very brief. 0.92. What is the ratio of the Expenses (in $) in Congo (Democratic) in 2005 to that in 2008?
Your answer should be very brief. 0.31. What is the ratio of the Expenses (in $) of Oman in 2005 to that in 2008?
Offer a terse response. 0.39. What is the ratio of the Expenses (in $) in Suriname in 2005 to that in 2008?
Offer a terse response. 0.77. What is the ratio of the Expenses (in $) in Austria in 2005 to that in 2009?
Make the answer very short. 20.43. What is the ratio of the Expenses (in $) in Congo (Democratic) in 2005 to that in 2009?
Offer a terse response. 0.26. What is the ratio of the Expenses (in $) in Oman in 2005 to that in 2009?
Your response must be concise. 0.56. What is the ratio of the Expenses (in $) of Suriname in 2005 to that in 2009?
Your answer should be compact. 0.81. What is the ratio of the Expenses (in $) of Congo (Democratic) in 2006 to that in 2007?
Give a very brief answer. 0.67. What is the ratio of the Expenses (in $) of Oman in 2006 to that in 2007?
Your response must be concise. 0.72. What is the ratio of the Expenses (in $) in Suriname in 2006 to that in 2007?
Provide a succinct answer. 0.87. What is the ratio of the Expenses (in $) of Congo (Democratic) in 2006 to that in 2008?
Offer a very short reply. 0.43. What is the ratio of the Expenses (in $) in Oman in 2006 to that in 2008?
Give a very brief answer. 0.51. What is the ratio of the Expenses (in $) of Suriname in 2006 to that in 2008?
Your answer should be very brief. 0.72. What is the ratio of the Expenses (in $) of Austria in 2006 to that in 2009?
Offer a terse response. 1. What is the ratio of the Expenses (in $) of Congo (Democratic) in 2006 to that in 2009?
Ensure brevity in your answer.  0.36. What is the ratio of the Expenses (in $) of Oman in 2006 to that in 2009?
Your response must be concise. 0.72. What is the ratio of the Expenses (in $) of Suriname in 2006 to that in 2009?
Ensure brevity in your answer.  0.76. What is the ratio of the Expenses (in $) of Congo (Democratic) in 2007 to that in 2008?
Offer a terse response. 0.64. What is the ratio of the Expenses (in $) of Oman in 2007 to that in 2008?
Offer a very short reply. 0.7. What is the ratio of the Expenses (in $) in Suriname in 2007 to that in 2008?
Ensure brevity in your answer.  0.83. What is the ratio of the Expenses (in $) in Congo (Democratic) in 2007 to that in 2009?
Ensure brevity in your answer.  0.54. What is the ratio of the Expenses (in $) of Oman in 2007 to that in 2009?
Make the answer very short. 1.01. What is the ratio of the Expenses (in $) of Suriname in 2007 to that in 2009?
Provide a short and direct response. 0.87. What is the ratio of the Expenses (in $) of Congo (Democratic) in 2008 to that in 2009?
Your answer should be very brief. 0.84. What is the ratio of the Expenses (in $) in Oman in 2008 to that in 2009?
Your answer should be very brief. 1.43. What is the ratio of the Expenses (in $) in Suriname in 2008 to that in 2009?
Your answer should be compact. 1.05. What is the difference between the highest and the second highest Expenses (in $) of Austria?
Keep it short and to the point. 2.51e+06. What is the difference between the highest and the second highest Expenses (in $) in Congo (Democratic)?
Keep it short and to the point. 6.80e+1. What is the difference between the highest and the second highest Expenses (in $) in Oman?
Your answer should be compact. 6.70e+07. What is the difference between the highest and the second highest Expenses (in $) in Suriname?
Provide a short and direct response. 1.01e+07. What is the difference between the highest and the lowest Expenses (in $) in Austria?
Your answer should be very brief. 3.94e+06. What is the difference between the highest and the lowest Expenses (in $) in Congo (Democratic)?
Offer a terse response. 3.89e+11. What is the difference between the highest and the lowest Expenses (in $) in Oman?
Provide a succinct answer. 1.66e+08. What is the difference between the highest and the lowest Expenses (in $) in Suriname?
Offer a very short reply. 1.15e+08. 